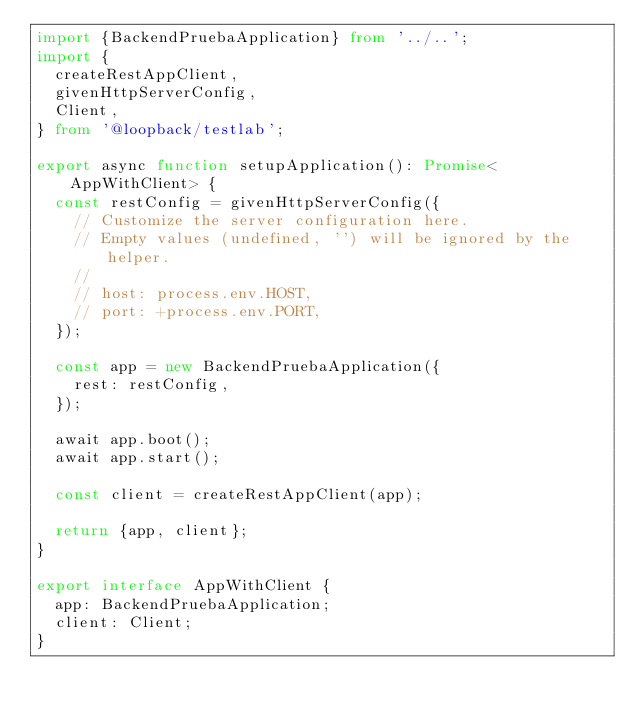<code> <loc_0><loc_0><loc_500><loc_500><_TypeScript_>import {BackendPruebaApplication} from '../..';
import {
  createRestAppClient,
  givenHttpServerConfig,
  Client,
} from '@loopback/testlab';

export async function setupApplication(): Promise<AppWithClient> {
  const restConfig = givenHttpServerConfig({
    // Customize the server configuration here.
    // Empty values (undefined, '') will be ignored by the helper.
    //
    // host: process.env.HOST,
    // port: +process.env.PORT,
  });

  const app = new BackendPruebaApplication({
    rest: restConfig,
  });

  await app.boot();
  await app.start();

  const client = createRestAppClient(app);

  return {app, client};
}

export interface AppWithClient {
  app: BackendPruebaApplication;
  client: Client;
}
</code> 